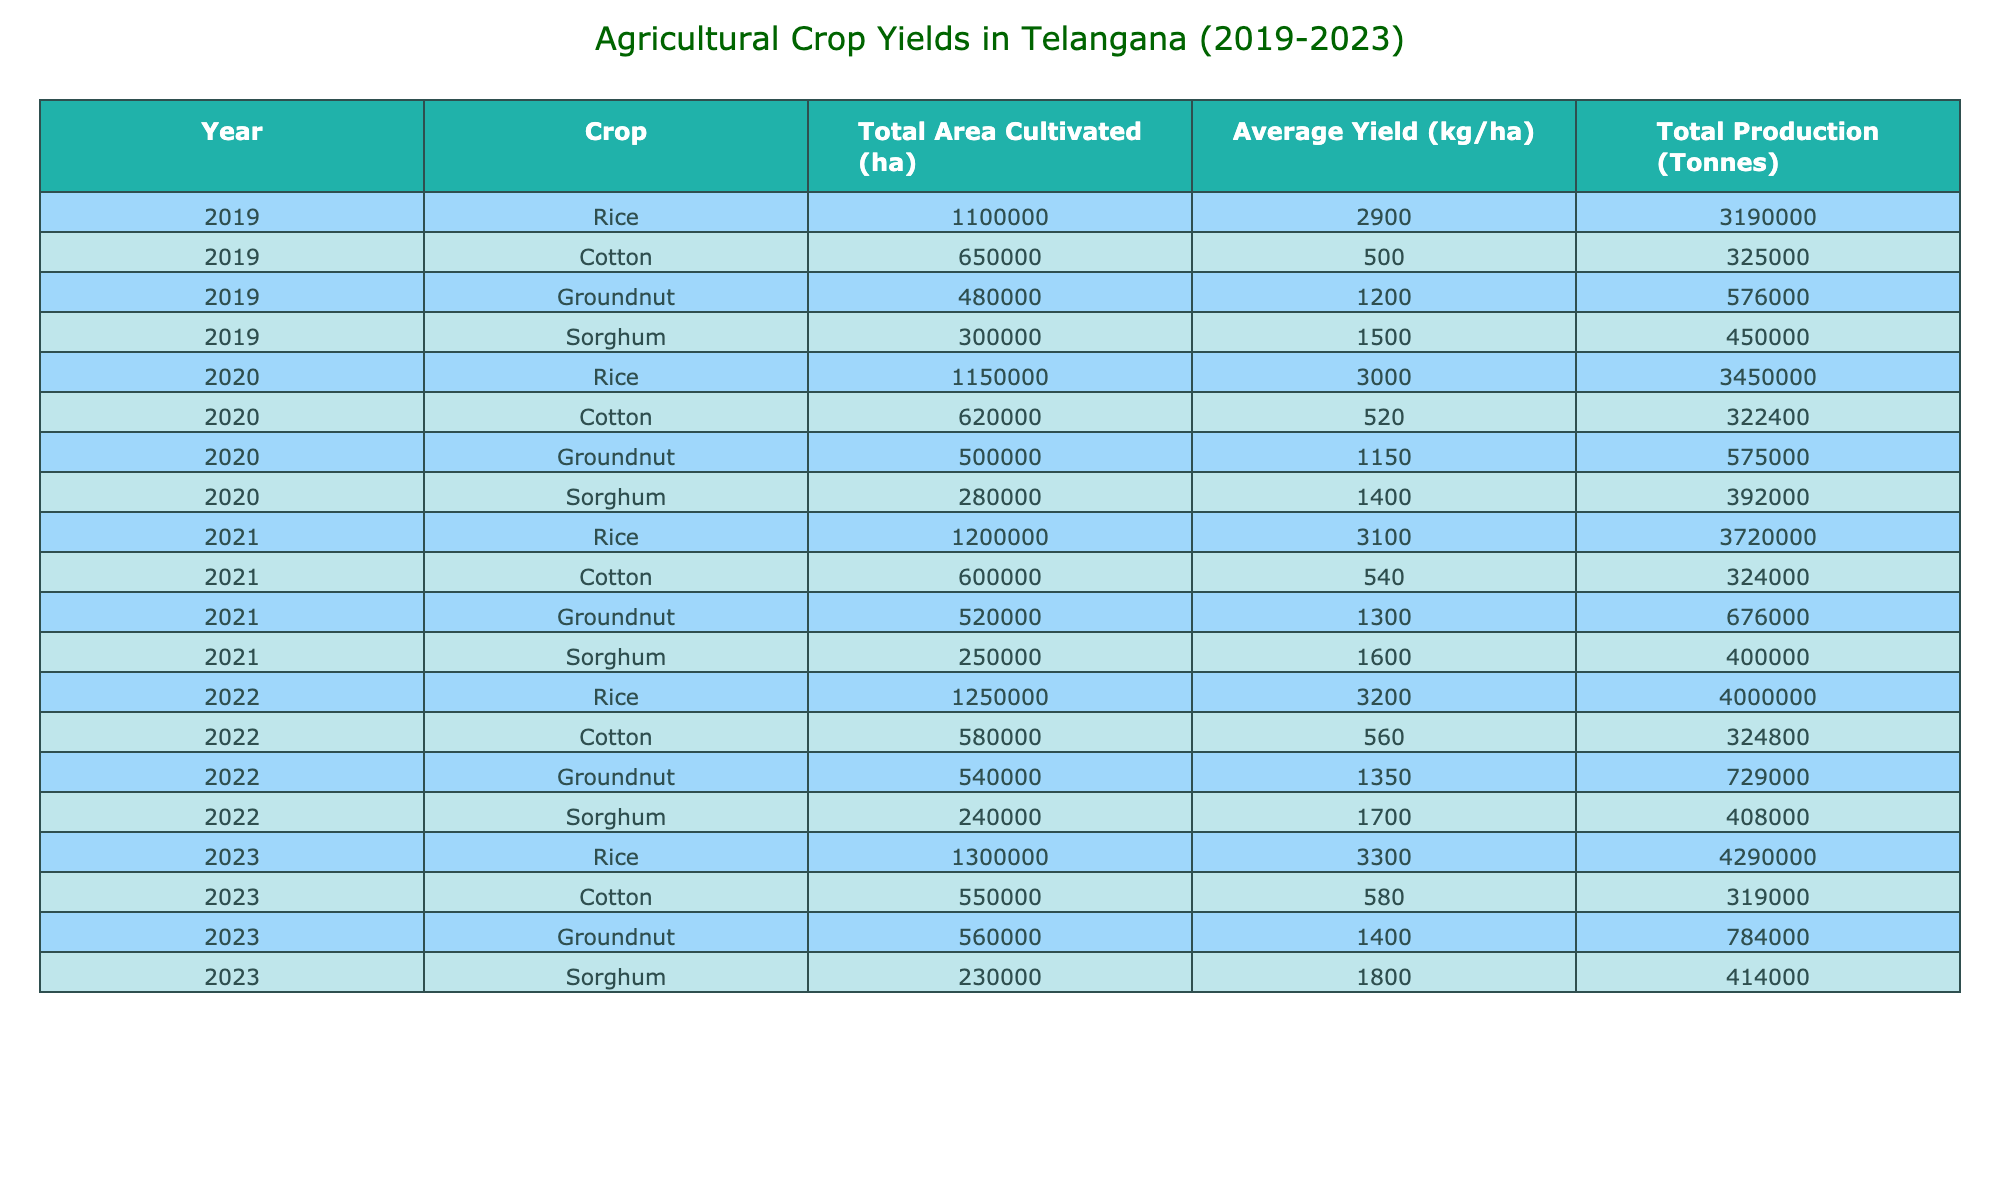What's the average yield of Rice in 2022? The yield of Rice in 2022 is given as 3200 kg/ha. There is only one data point for Rice in 2022, so the average yield is simply 3200 kg/ha.
Answer: 3200 kg/ha What was the total production of Groundnut in 2023? From the table, the total production of Groundnut in 2023 is listed as 784000 Tonnes.
Answer: 784000 Tonnes Did the total area cultivated for Cotton decrease from 2022 to 2023? The total area cultivated for Cotton in 2022 is 580000 ha and in 2023 it is 550000 ha. Since 550000 is less than 580000, this means there was a decrease.
Answer: Yes Which crop had the highest average yield in 2021? The average yield data for each crop in 2021 shows Rice at 3100 kg/ha, Cotton at 540 kg/ha, Groundnut at 1300 kg/ha, and Sorghum at 1600 kg/ha. With 3100 kg/ha being the highest value, it is concluded that Rice had the highest average yield in 2021.
Answer: Rice What was the total production of all crops in 2020? The total production for each crop in 2020 is Rice 3450000 Tonnes, Cotton 322400 Tonnes, Groundnut 575000 Tonnes, and Sorghum 392000 Tonnes. Summing these yields gives (3450000 + 322400 + 575000 + 392000) = 4774400 Tonnes.
Answer: 4774400 Tonnes Which year saw the largest increase in Rice yield compared to the previous year? The yields of Rice were 2900 kg/ha in 2019, 3000 kg/ha in 2020, 3100 kg/ha in 2021, 3200 kg/ha in 2022, and 3300 kg/ha in 2023. The increases from 2019 to 2020 is 100, from 2020 to 2021 is 100, from 2021 to 2022 is 100, and from 2022 to 2023 is also 100. Hence, the increase was consistent and the maximum year-to-year increase is 100 kg/ha.
Answer: None (consistent increase) Is the average yield of Sorghum in 2023 higher or lower than in 2020? The average yield of Sorghum in 2020 is recorded as 1400 kg/ha and in 2023 as 1800 kg/ha. Since 1800 is greater than 1400, this indicates that the average yield of Sorghum increased.
Answer: Higher What is the total area cultivated for all crops in 2022? The area cultivated for Rice in 2022 is 1250000 ha, Cotton is 580000 ha, Groundnut is 540000 ha, and Sorghum is 240000 ha. Summing these areas gives (1250000 + 580000 + 540000 + 240000) = 2010000 ha.
Answer: 2010000 ha 